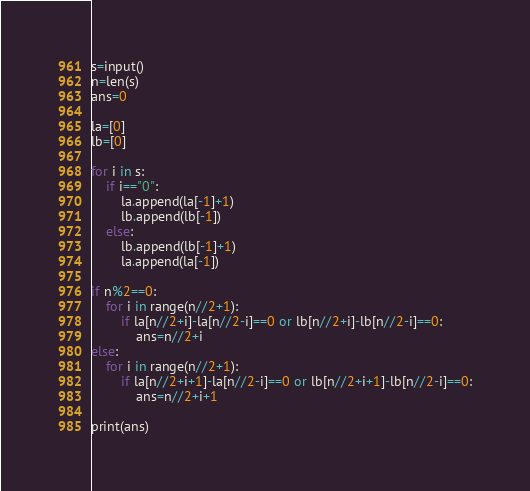<code> <loc_0><loc_0><loc_500><loc_500><_Python_>s=input()
n=len(s)
ans=0

la=[0]
lb=[0]

for i in s:
    if i=="0":
        la.append(la[-1]+1)
        lb.append(lb[-1])
    else:
        lb.append(lb[-1]+1)
        la.append(la[-1])

if n%2==0:
    for i in range(n//2+1):
        if la[n//2+i]-la[n//2-i]==0 or lb[n//2+i]-lb[n//2-i]==0:
            ans=n//2+i
else:
    for i in range(n//2+1):
        if la[n//2+i+1]-la[n//2-i]==0 or lb[n//2+i+1]-lb[n//2-i]==0:
            ans=n//2+i+1

print(ans)</code> 